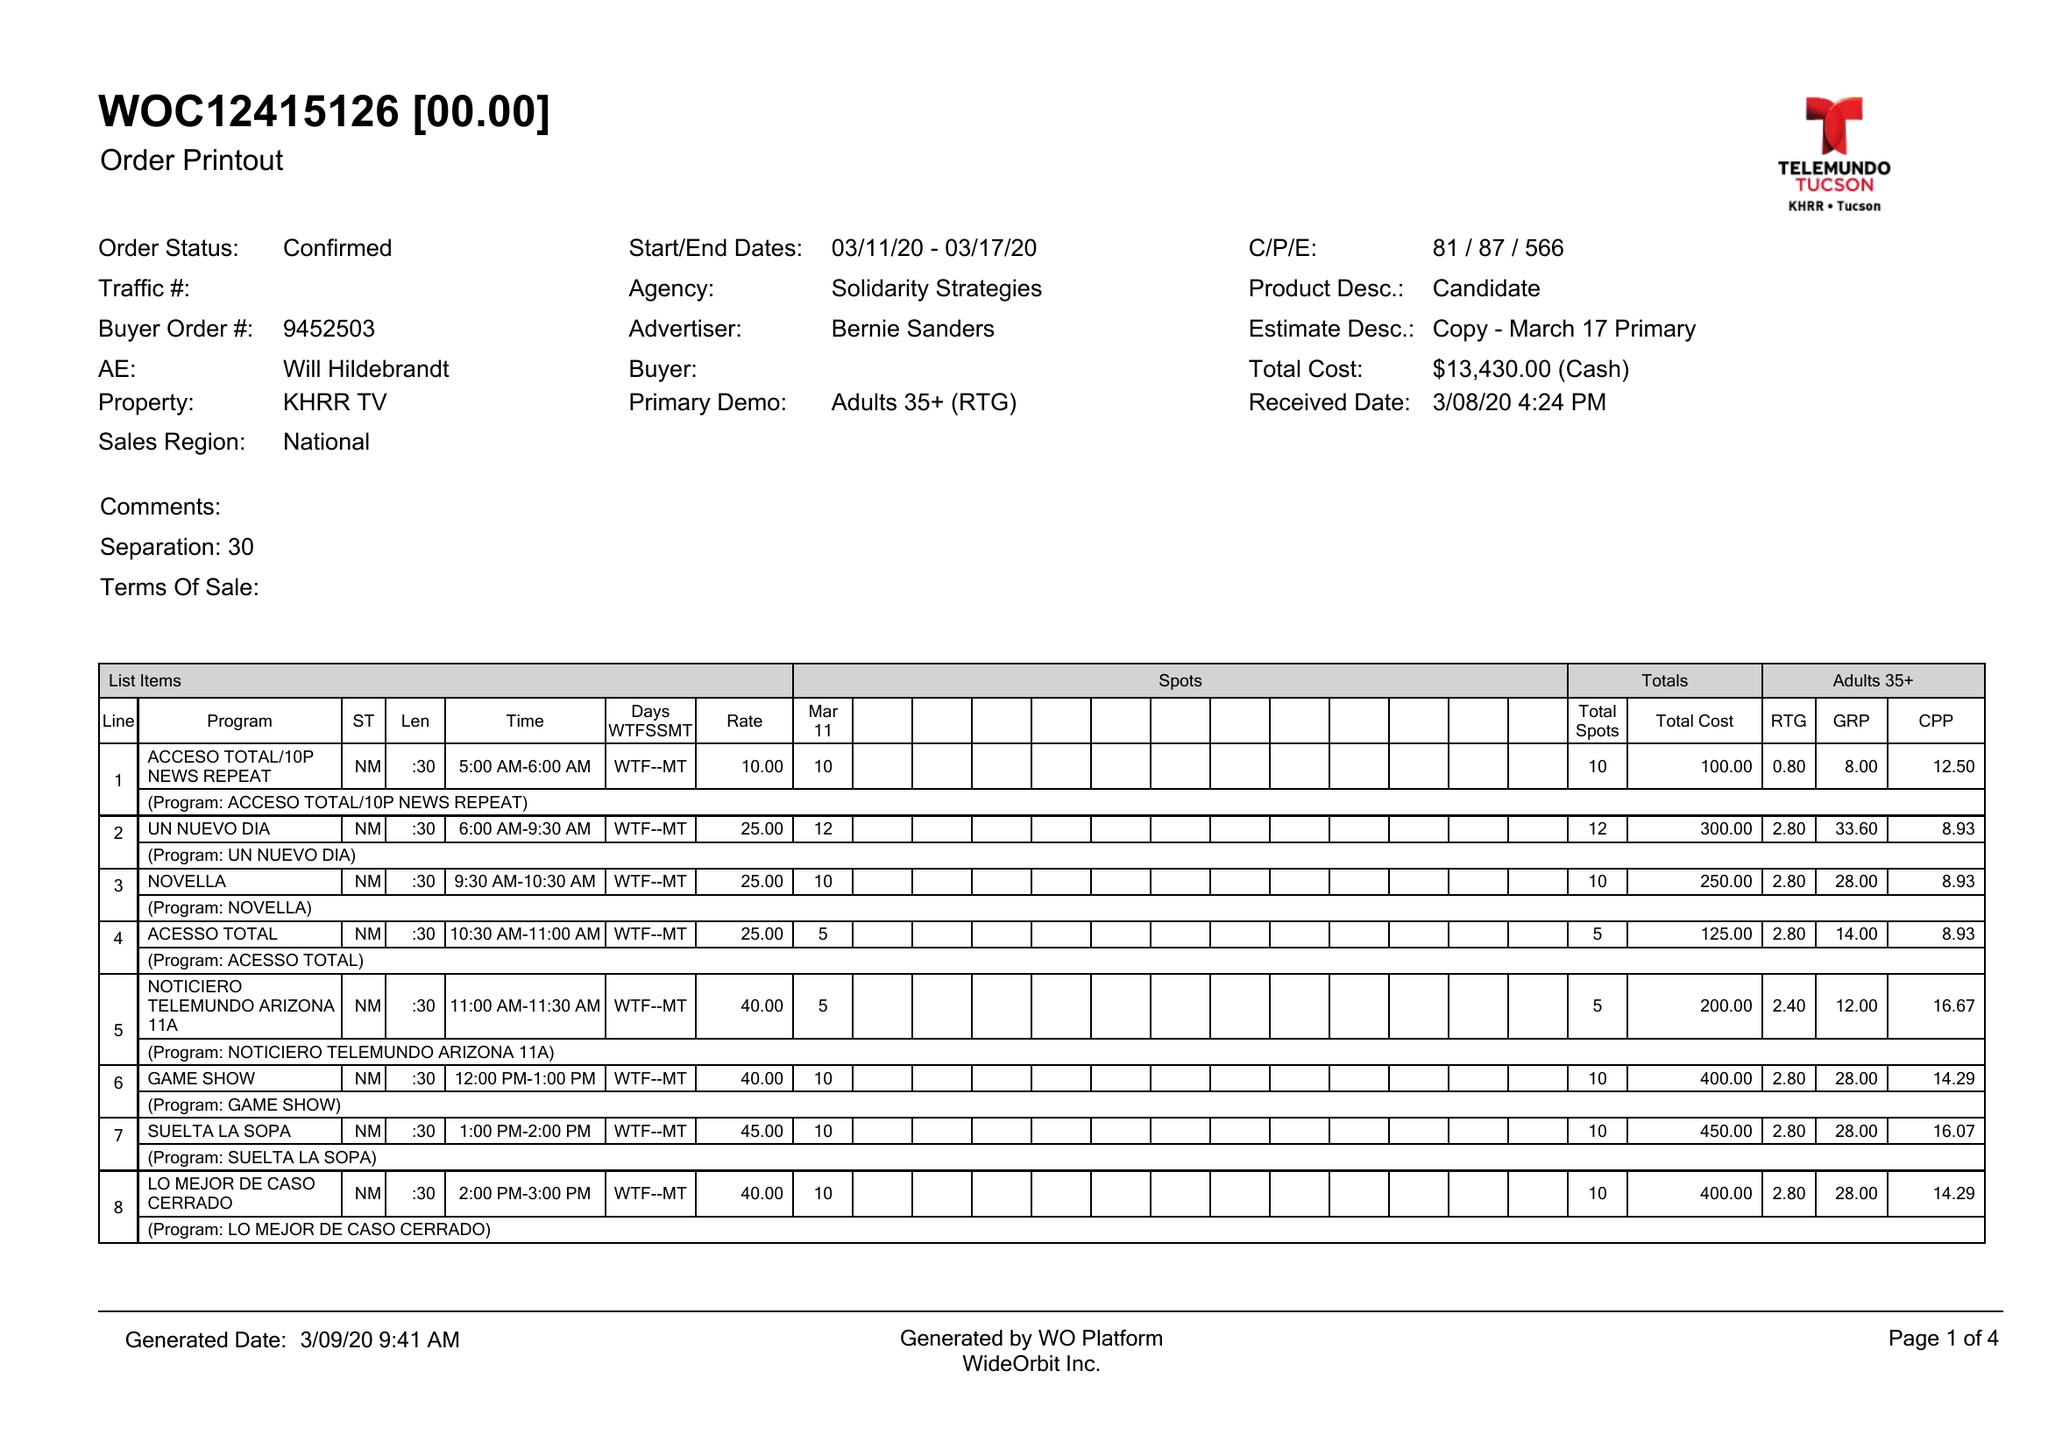What is the value for the flight_from?
Answer the question using a single word or phrase. 03/11/20 